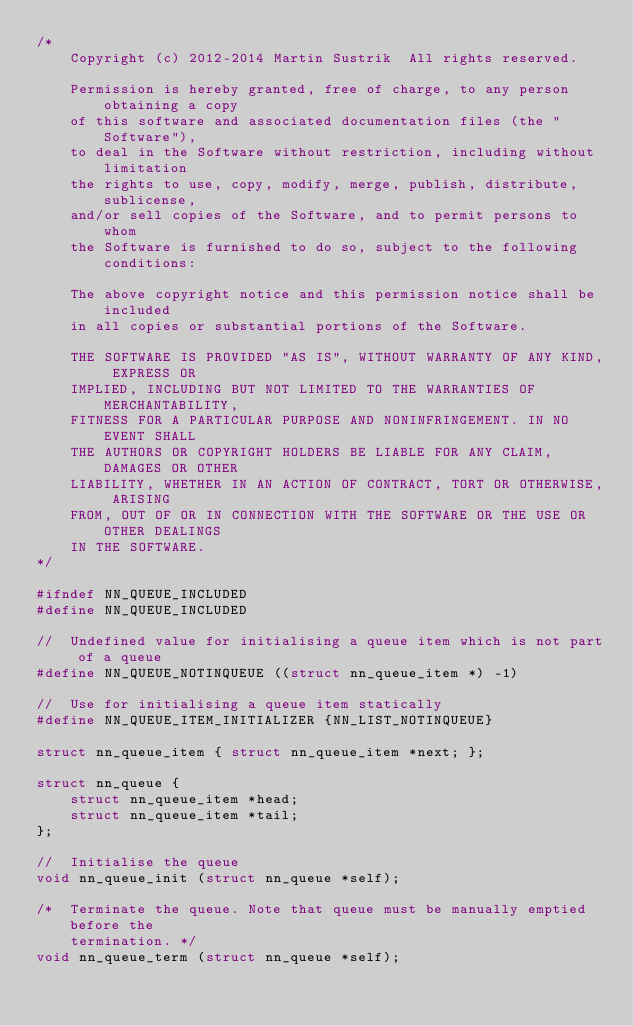<code> <loc_0><loc_0><loc_500><loc_500><_C_>/*
    Copyright (c) 2012-2014 Martin Sustrik  All rights reserved.

    Permission is hereby granted, free of charge, to any person obtaining a copy
    of this software and associated documentation files (the "Software"),
    to deal in the Software without restriction, including without limitation
    the rights to use, copy, modify, merge, publish, distribute, sublicense,
    and/or sell copies of the Software, and to permit persons to whom
    the Software is furnished to do so, subject to the following conditions:

    The above copyright notice and this permission notice shall be included
    in all copies or substantial portions of the Software.

    THE SOFTWARE IS PROVIDED "AS IS", WITHOUT WARRANTY OF ANY KIND, EXPRESS OR
    IMPLIED, INCLUDING BUT NOT LIMITED TO THE WARRANTIES OF MERCHANTABILITY,
    FITNESS FOR A PARTICULAR PURPOSE AND NONINFRINGEMENT. IN NO EVENT SHALL
    THE AUTHORS OR COPYRIGHT HOLDERS BE LIABLE FOR ANY CLAIM, DAMAGES OR OTHER
    LIABILITY, WHETHER IN AN ACTION OF CONTRACT, TORT OR OTHERWISE, ARISING
    FROM, OUT OF OR IN CONNECTION WITH THE SOFTWARE OR THE USE OR OTHER DEALINGS
    IN THE SOFTWARE.
*/

#ifndef NN_QUEUE_INCLUDED
#define NN_QUEUE_INCLUDED

//  Undefined value for initialising a queue item which is not part of a queue
#define NN_QUEUE_NOTINQUEUE ((struct nn_queue_item *) -1)

//  Use for initialising a queue item statically
#define NN_QUEUE_ITEM_INITIALIZER {NN_LIST_NOTINQUEUE}

struct nn_queue_item { struct nn_queue_item *next; };

struct nn_queue {
    struct nn_queue_item *head;
    struct nn_queue_item *tail;
};

//  Initialise the queue
void nn_queue_init (struct nn_queue *self);

/*  Terminate the queue. Note that queue must be manually emptied before the
    termination. */
void nn_queue_term (struct nn_queue *self);
</code> 